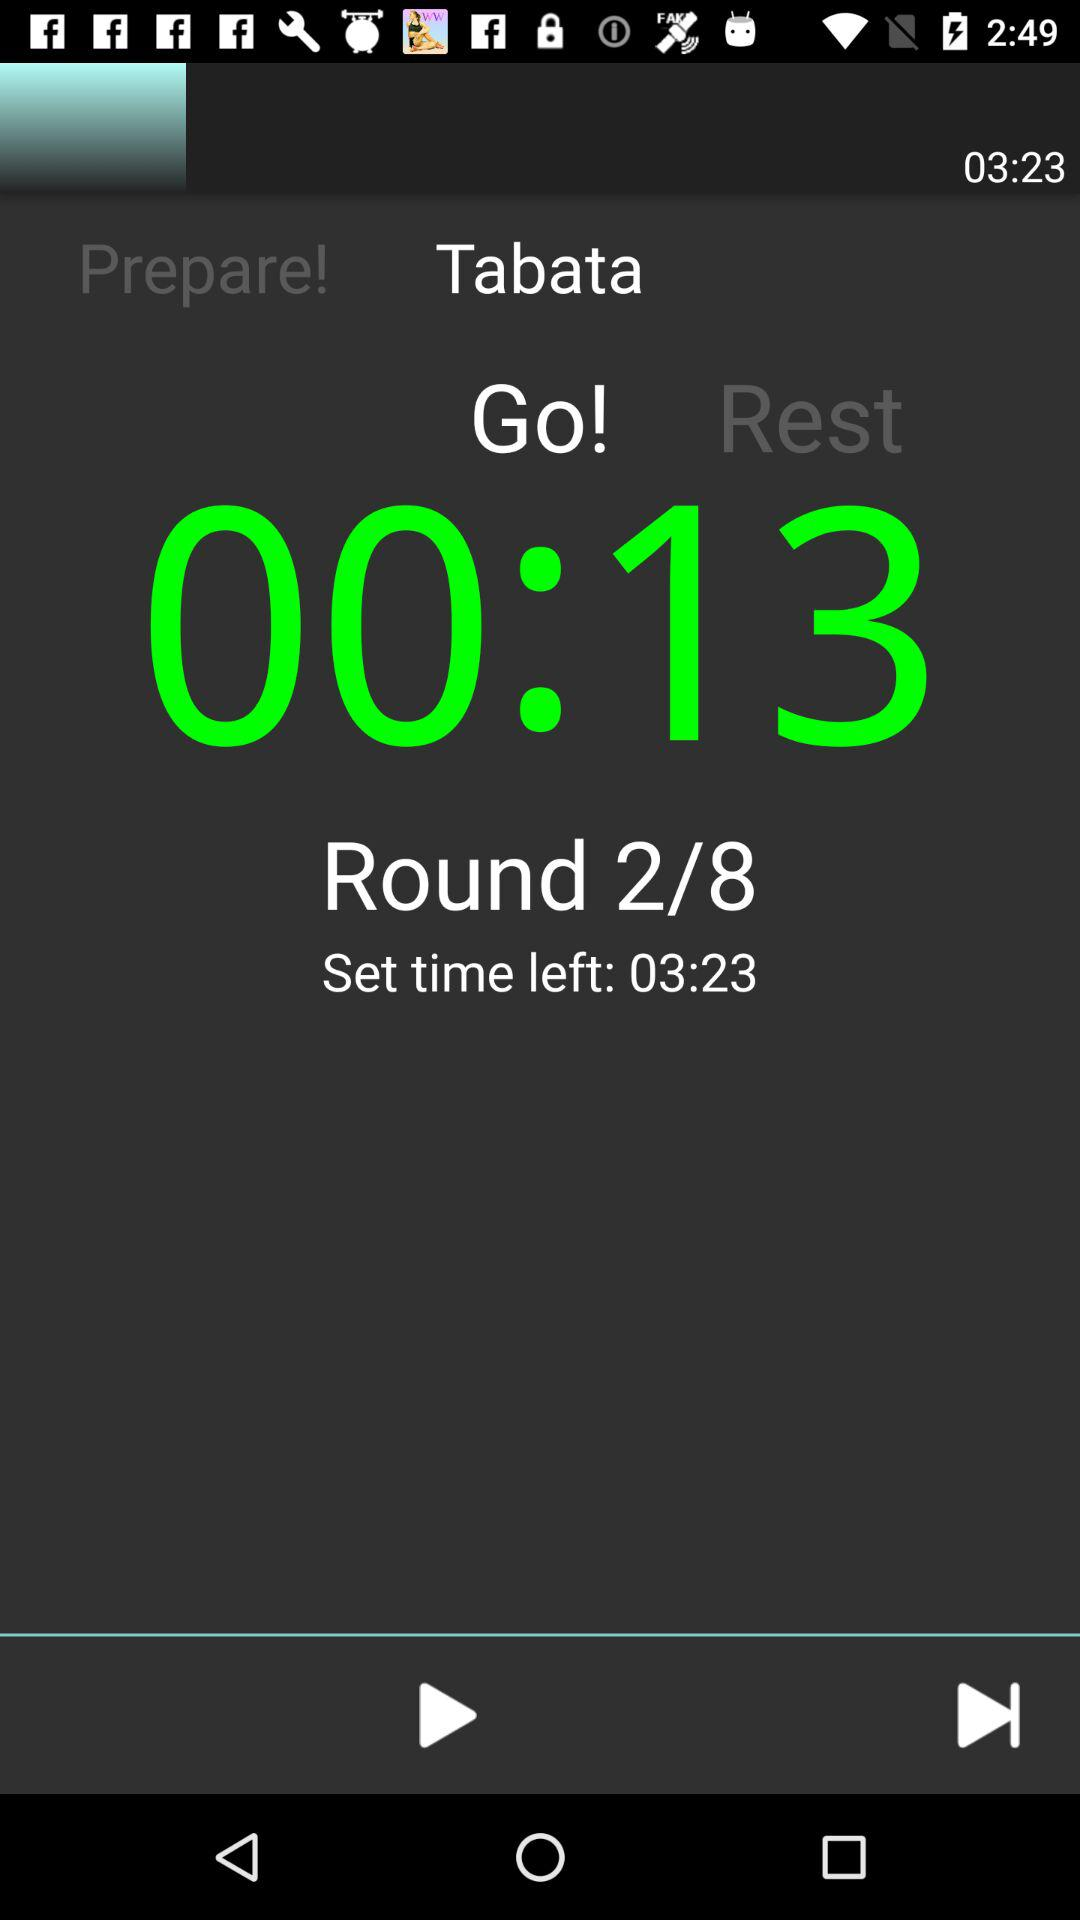What is the total number of rounds? The total number of rounds is 8. 